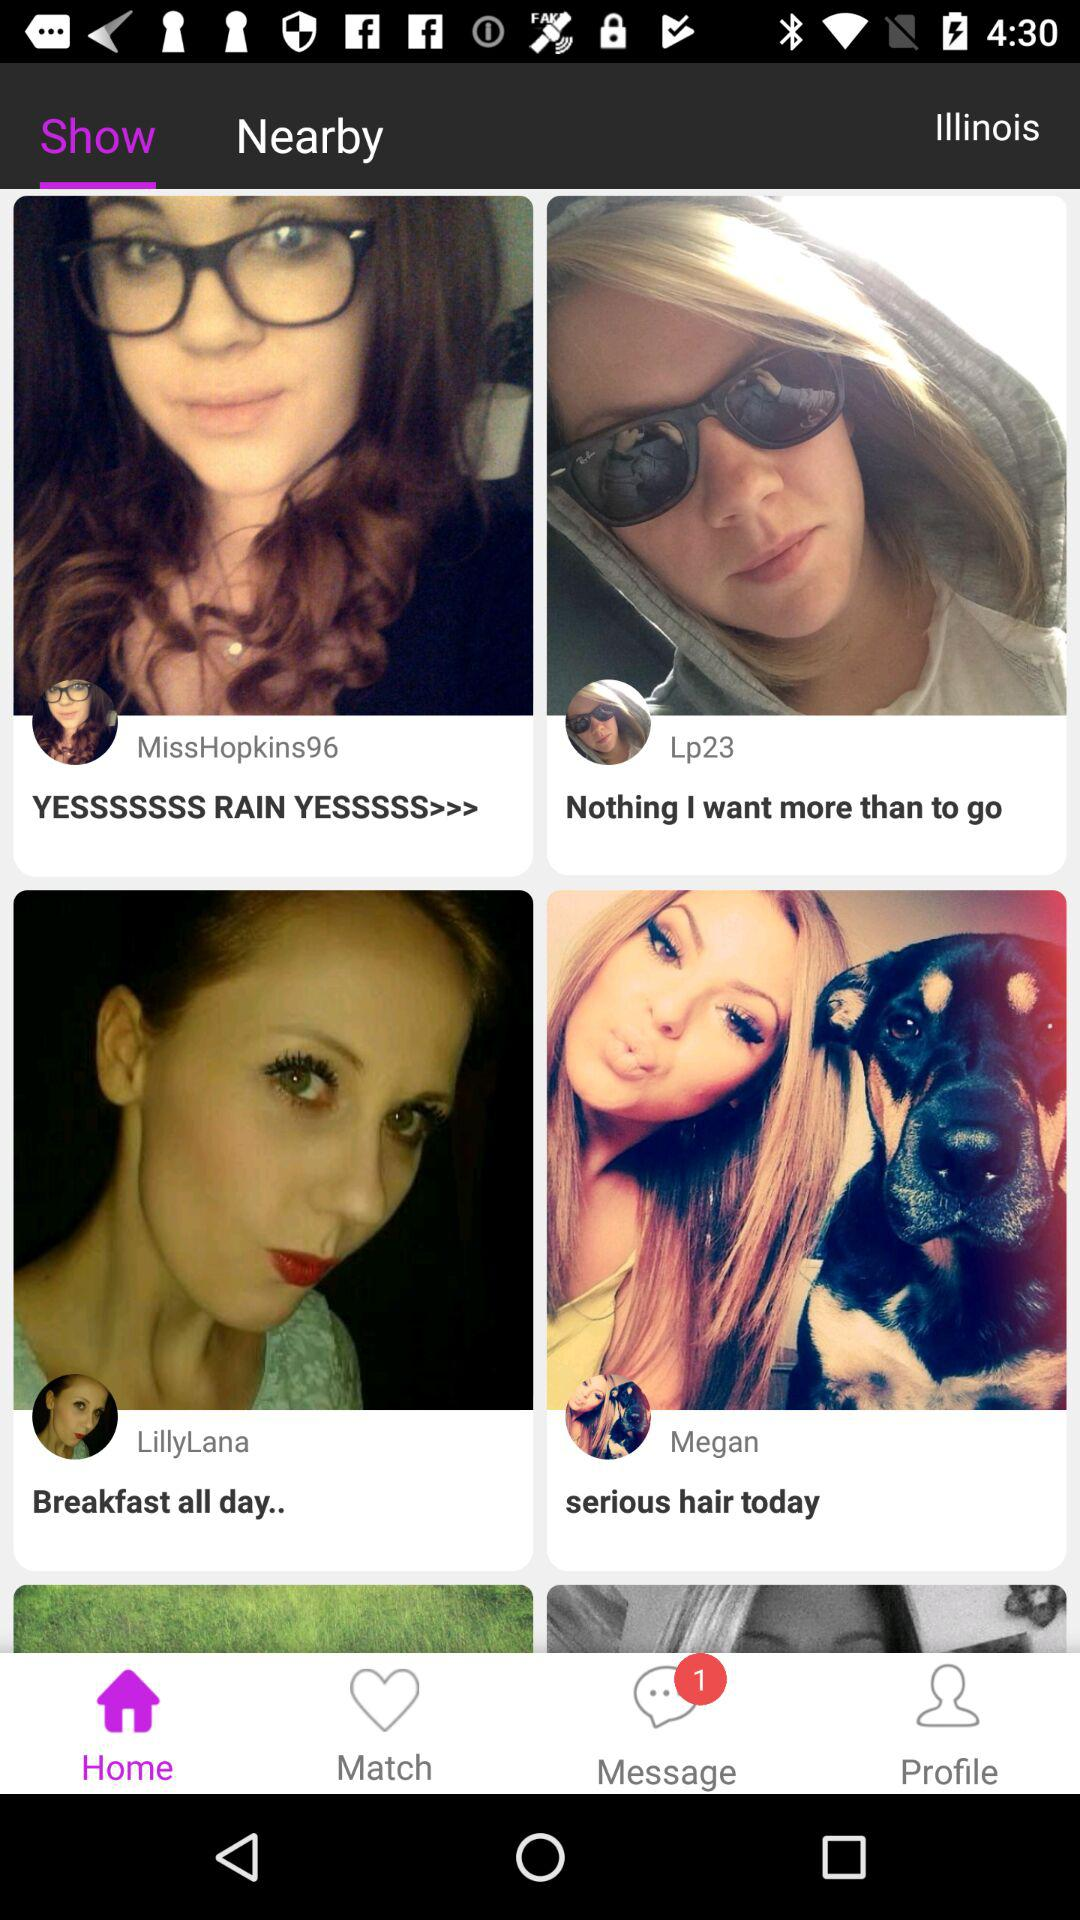Is there any unread message?
When the provided information is insufficient, respond with <no answer>. <no answer> 